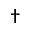Convert formula to latex. <formula><loc_0><loc_0><loc_500><loc_500>^ { \dagger }</formula> 